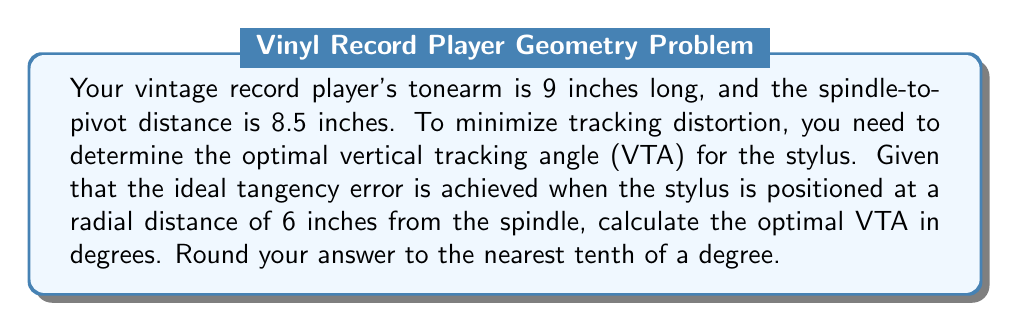Could you help me with this problem? Let's approach this step-by-step using trigonometry and calculus:

1) First, let's define our variables:
   $L$ = length of tonearm = 9 inches
   $D$ = spindle-to-pivot distance = 8.5 inches
   $r$ = optimal radial distance = 6 inches
   $\theta$ = vertical tracking angle (VTA)

2) We can visualize this as a right triangle, where the tonearm is the hypotenuse:

[asy]
import geometry;

size(200);

pair A = (0,0), B = (8.5,0), C = (6,0);
draw(A--B, arrow=Arrow(TeXHead));
draw(A--C, arrow=Arrow(TeXHead));
draw(B--(6,4.5), arrow=Arrow(TeXHead));

label("D = 8.5", (4.25,-0.5));
label("r = 6", (3,-0.5));
label("L = 9", (7.25,2.5), E);
label("θ", (8.5,0.5), NE);

dot("A (spindle)", A, SW);
dot("B (pivot)", B, SE);
dot("C (stylus)", C, S);
[/asy]

3) The horizontal distance from the stylus to the pivot is $(D - r) = 8.5 - 6 = 2.5$ inches.

4) We can use the Pythagorean theorem to find the vertical height $h$:

   $$L^2 = h^2 + (D-r)^2$$
   $$9^2 = h^2 + 2.5^2$$
   $$h = \sqrt{9^2 - 2.5^2} \approx 8.6603$$

5) Now, we can calculate $\theta$ using the inverse tangent function:

   $$\theta = \tan^{-1}\left(\frac{h}{D-r}\right)$$
   $$\theta = \tan^{-1}\left(\frac{8.6603}{2.5}\right)$$

6) Using a calculator or computer, we can evaluate this:

   $$\theta \approx 73.9°$$

7) Rounding to the nearest tenth of a degree gives us 73.9°.
Answer: The optimal vertical tracking angle (VTA) is approximately 73.9°. 